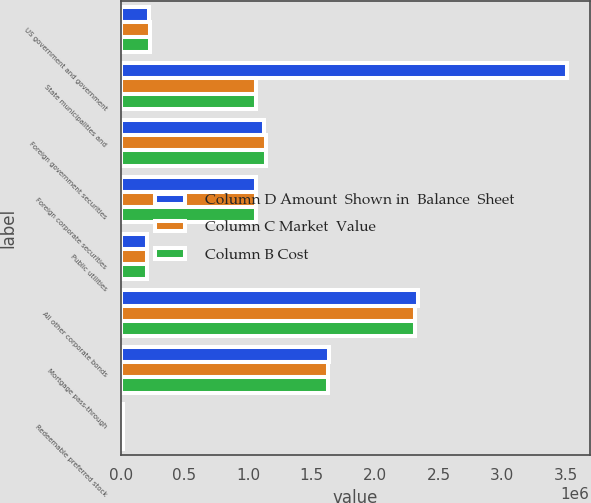Convert chart. <chart><loc_0><loc_0><loc_500><loc_500><stacked_bar_chart><ecel><fcel>US government and government<fcel>State municipalities and<fcel>Foreign government securities<fcel>Foreign corporate securities<fcel>Public utilities<fcel>All other corporate bonds<fcel>Mortgage pass-through<fcel>Redeemable preferred stock<nl><fcel>Column D Amount  Shown in  Balance  Sheet<fcel>224563<fcel>3.51269e+06<fcel>1.12299e+06<fcel>1.06176e+06<fcel>205186<fcel>2.33596e+06<fcel>1.63654e+06<fcel>16654<nl><fcel>Column C Market  Value<fcel>231621<fcel>1.06137e+06<fcel>1.14162e+06<fcel>1.06097e+06<fcel>203095<fcel>2.31594e+06<fcel>1.62724e+06<fcel>16573<nl><fcel>Column B Cost<fcel>231621<fcel>1.06137e+06<fcel>1.14162e+06<fcel>1.06097e+06<fcel>203095<fcel>2.31594e+06<fcel>1.62724e+06<fcel>16573<nl></chart> 